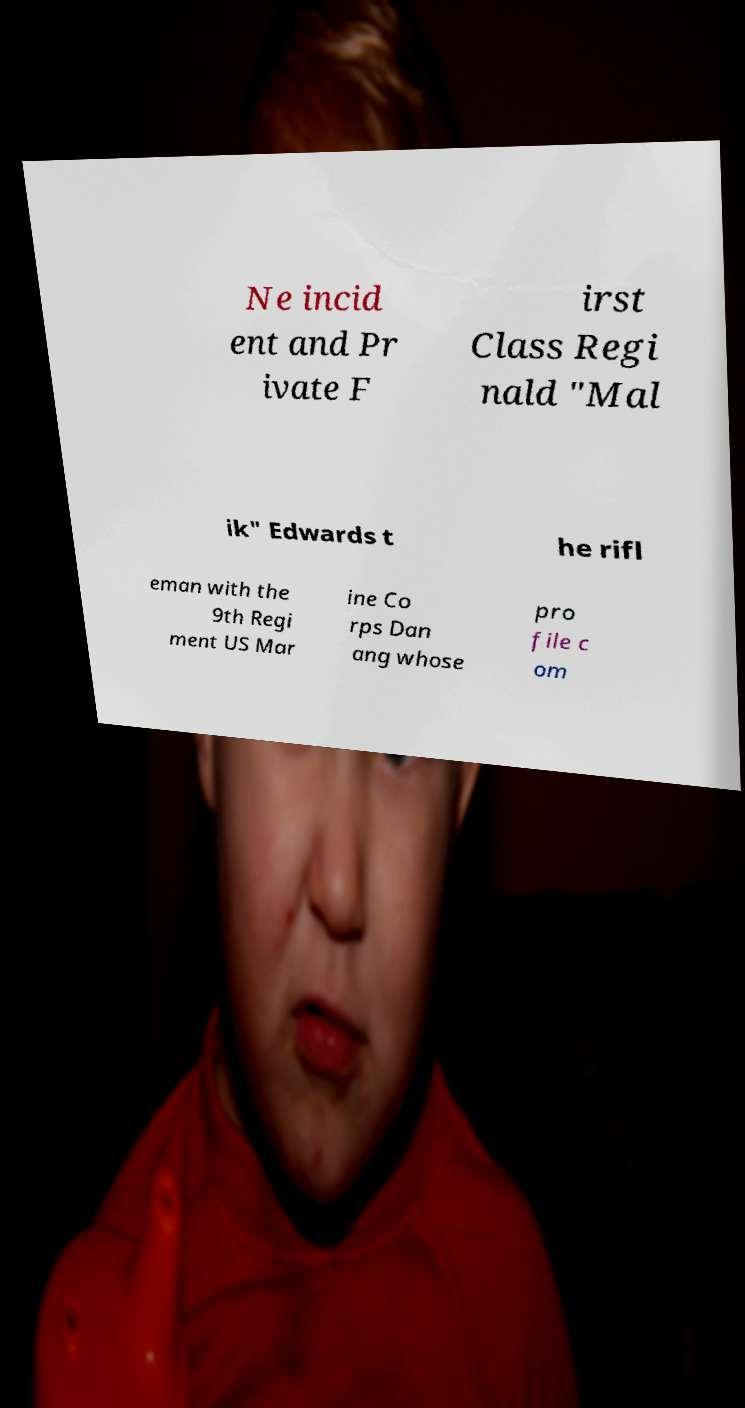Please identify and transcribe the text found in this image. Ne incid ent and Pr ivate F irst Class Regi nald "Mal ik" Edwards t he rifl eman with the 9th Regi ment US Mar ine Co rps Dan ang whose pro file c om 